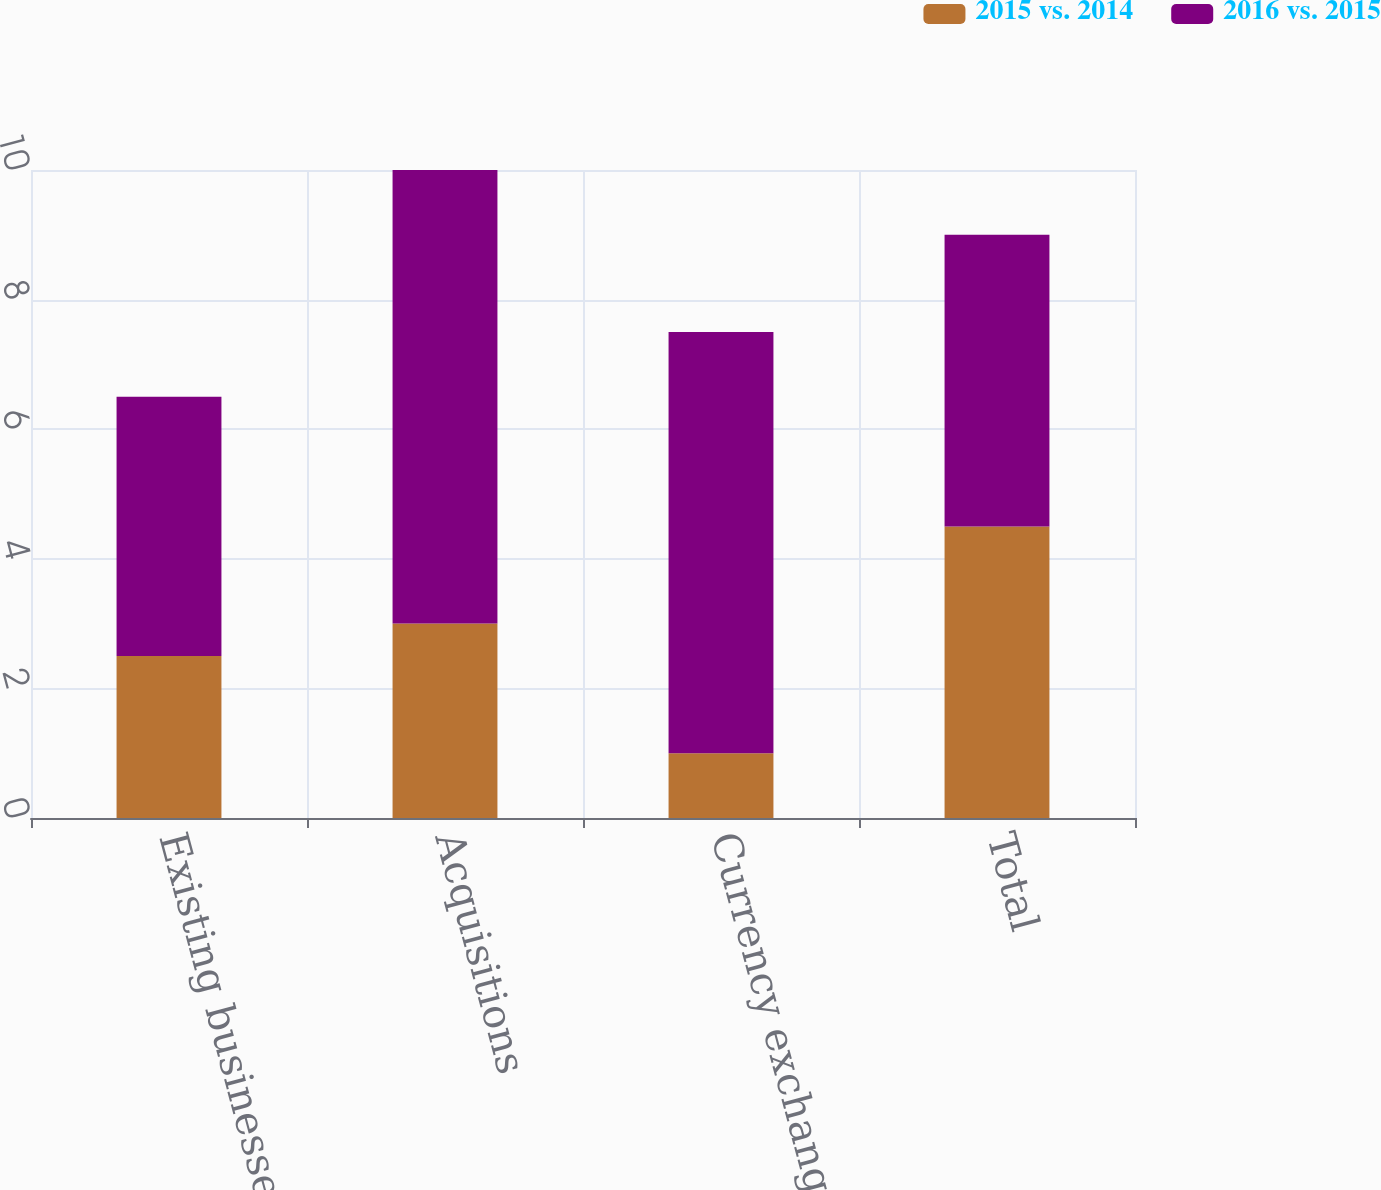Convert chart to OTSL. <chart><loc_0><loc_0><loc_500><loc_500><stacked_bar_chart><ecel><fcel>Existing businesses<fcel>Acquisitions<fcel>Currency exchange rates<fcel>Total<nl><fcel>2015 vs. 2014<fcel>2.5<fcel>3<fcel>1<fcel>4.5<nl><fcel>2016 vs. 2015<fcel>4<fcel>7<fcel>6.5<fcel>4.5<nl></chart> 